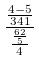Convert formula to latex. <formula><loc_0><loc_0><loc_500><loc_500>\frac { \frac { 4 - 5 } { 3 4 1 } } { \frac { \frac { 6 2 } { 5 } } { 4 } }</formula> 